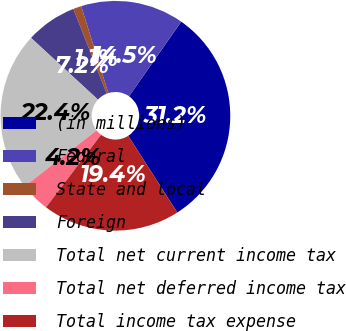Convert chart to OTSL. <chart><loc_0><loc_0><loc_500><loc_500><pie_chart><fcel>(in millions)<fcel>Federal<fcel>State and local<fcel>Foreign<fcel>Total net current income tax<fcel>Total net deferred income tax<fcel>Total income tax expense<nl><fcel>31.24%<fcel>14.53%<fcel>1.15%<fcel>7.17%<fcel>22.39%<fcel>4.16%<fcel>19.38%<nl></chart> 